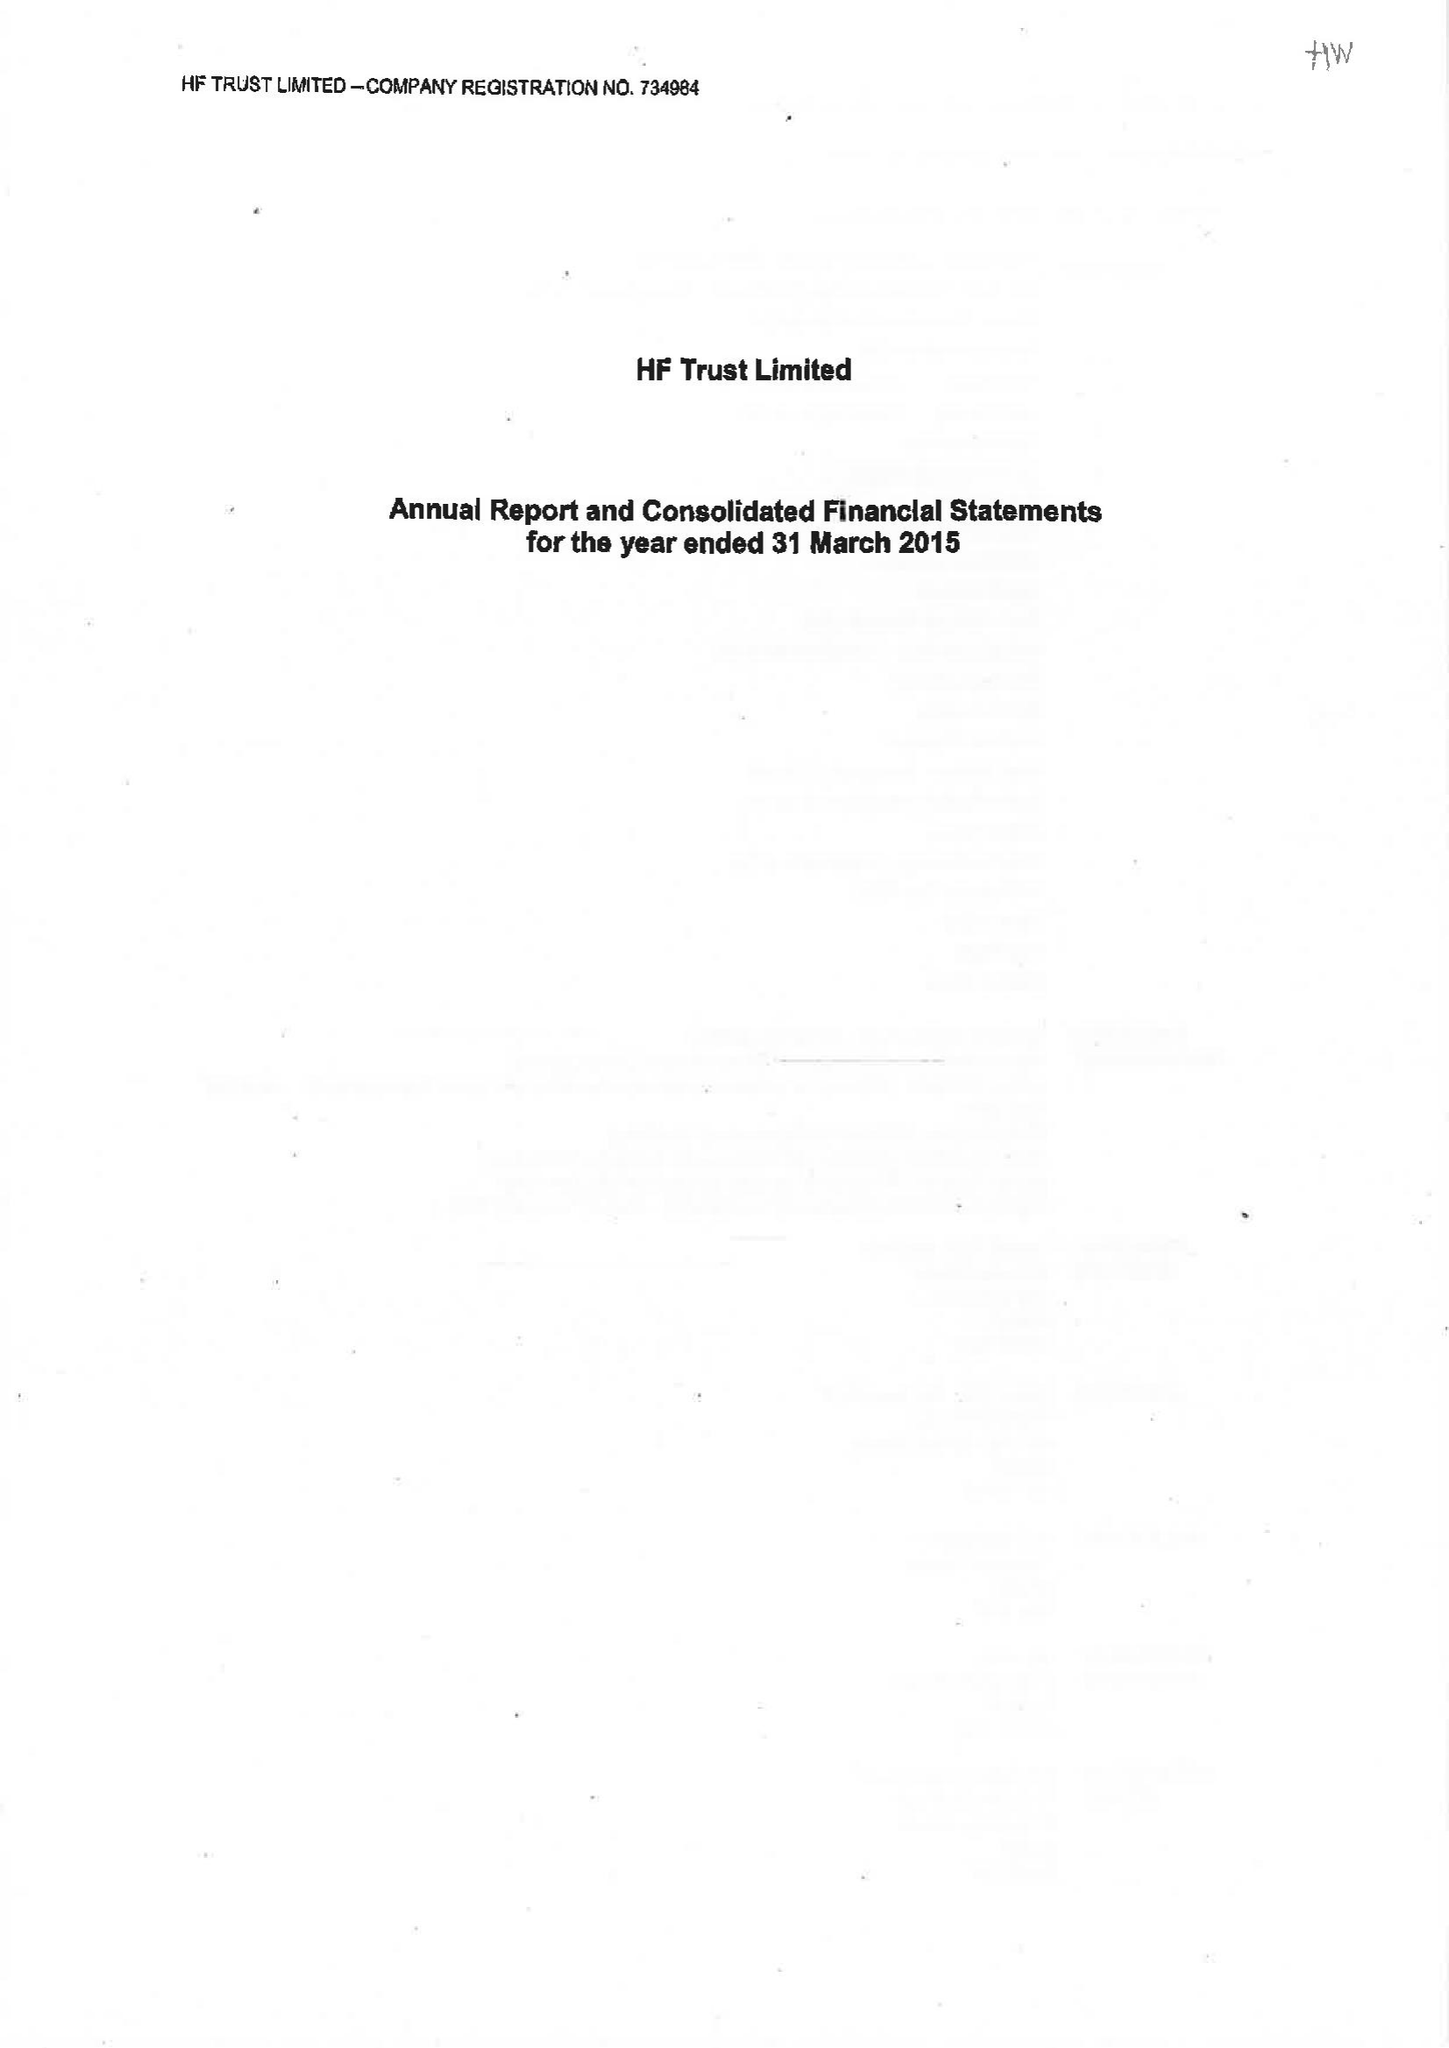What is the value for the address__post_town?
Answer the question using a single word or phrase. BRISTOL 